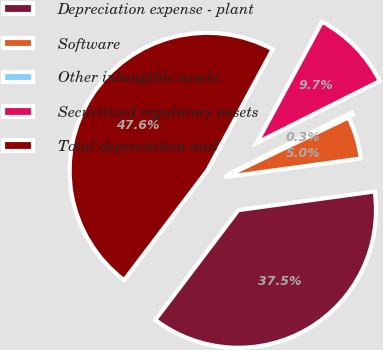Convert chart. <chart><loc_0><loc_0><loc_500><loc_500><pie_chart><fcel>Depreciation expense - plant<fcel>Software<fcel>Other intangible assets<fcel>Securitized regulatory assets<fcel>Total depreciation and<nl><fcel>37.48%<fcel>4.98%<fcel>0.25%<fcel>9.72%<fcel>47.56%<nl></chart> 